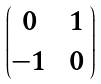Convert formula to latex. <formula><loc_0><loc_0><loc_500><loc_500>\begin{pmatrix} 0 & \, 1 \, \\ - 1 & 0 \end{pmatrix}</formula> 